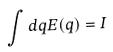Convert formula to latex. <formula><loc_0><loc_0><loc_500><loc_500>\int d q E ( q ) = I</formula> 